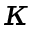Convert formula to latex. <formula><loc_0><loc_0><loc_500><loc_500>\kappa</formula> 